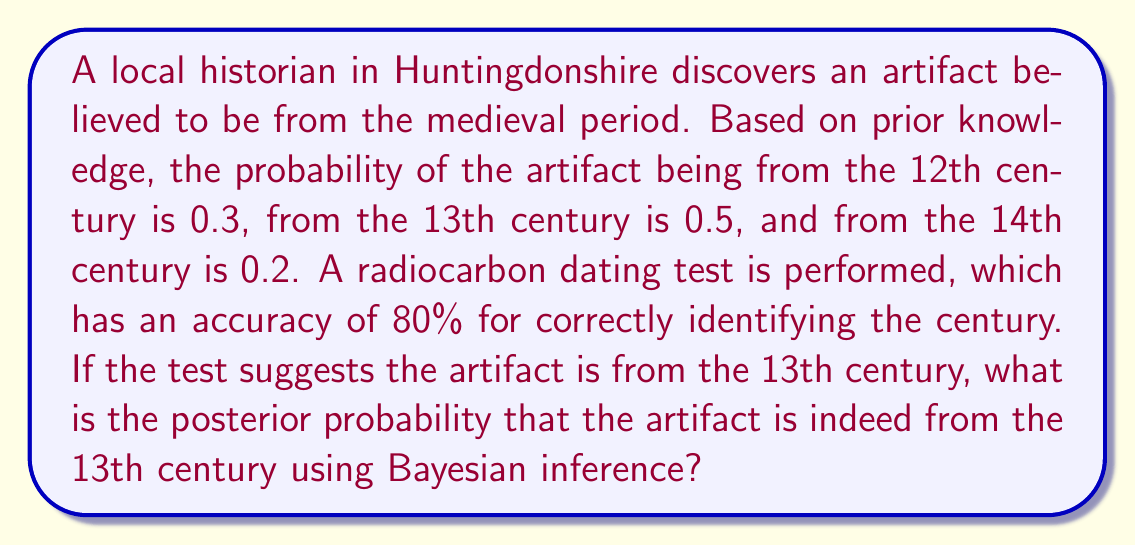Could you help me with this problem? Let's approach this problem using Bayesian inference:

1. Define the events:
   A: Artifact is from the 13th century
   T: Test suggests 13th century

2. Given probabilities:
   P(A) = 0.5 (prior probability)
   P(T|A) = 0.8 (test accuracy)
   P(T|not A) = 0.2 (false positive rate)

3. Calculate P(T) using the law of total probability:
   P(T) = P(T|A) * P(A) + P(T|not A) * P(not A)
   P(T) = 0.8 * 0.5 + 0.2 * 0.5 = 0.5

4. Apply Bayes' theorem:
   $$P(A|T) = \frac{P(T|A) * P(A)}{P(T)}$$

5. Substitute the values:
   $$P(A|T) = \frac{0.8 * 0.5}{0.5} = 0.8$$

Therefore, the posterior probability that the artifact is from the 13th century, given that the test suggests it is, is 0.8 or 80%.
Answer: 0.8 